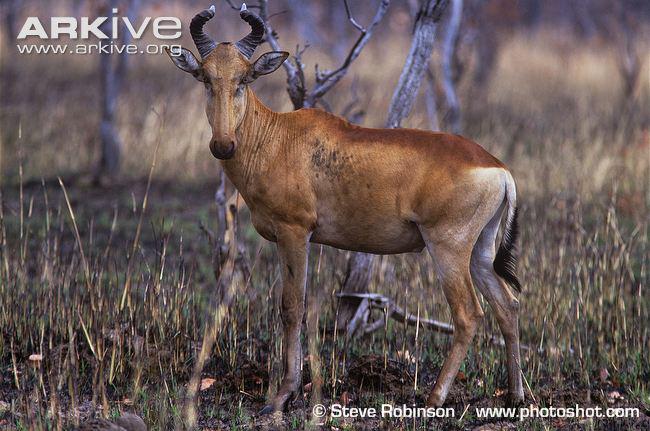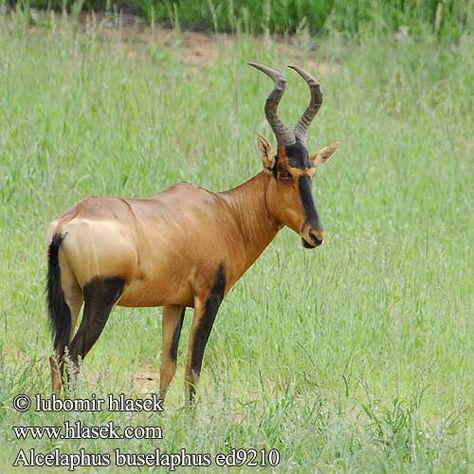The first image is the image on the left, the second image is the image on the right. Considering the images on both sides, is "The right image shows two antelope in the grass." valid? Answer yes or no. No. The first image is the image on the left, the second image is the image on the right. Evaluate the accuracy of this statement regarding the images: "The right image contains at twice as many horned animals as the left image.". Is it true? Answer yes or no. No. 